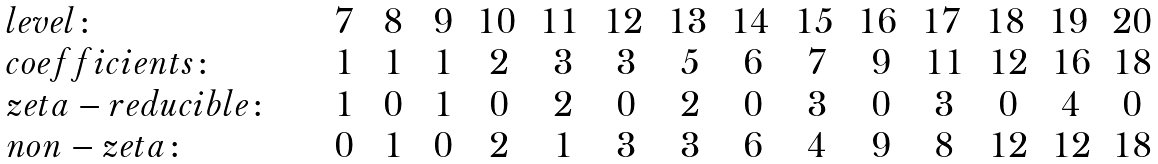Convert formula to latex. <formula><loc_0><loc_0><loc_500><loc_500>\begin{array} { l c c c c c c c c c c c c c c } l e v e l \colon & \, 7 \, & \, 8 \, & \, 9 \, & 1 0 \, & 1 1 \, & 1 2 \, & 1 3 \, & 1 4 \, & 1 5 \, & 1 6 \, & 1 7 \, & 1 8 \, & 1 9 \, & 2 0 \\ c o e f f i c i e n t s \colon & 1 & 1 & 1 & 2 & 3 & 3 & 5 & 6 & 7 & 9 & 1 1 & 1 2 & 1 6 & 1 8 \\ z e t a - r e d u c i b l e \colon \quad & 1 & 0 & 1 & 0 & 2 & 0 & 2 & 0 & 3 & 0 & 3 & 0 & 4 & 0 \\ n o n - z e t a \colon & 0 & 1 & 0 & 2 & 1 & 3 & 3 & 6 & 4 & 9 & 8 & 1 2 & 1 2 & 1 8 \end{array}</formula> 